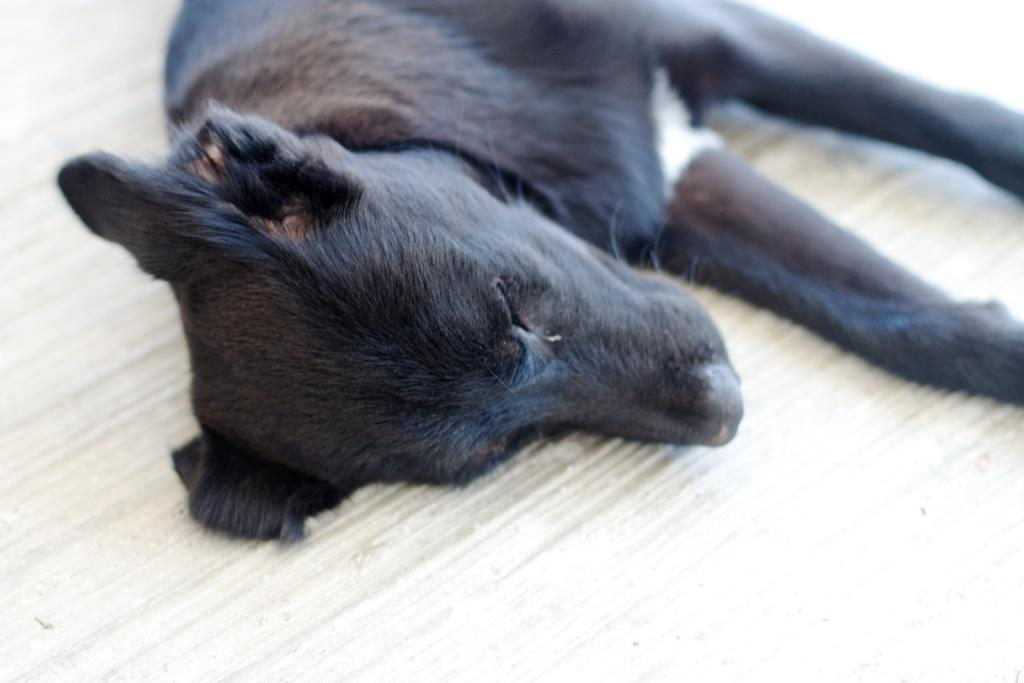What type of animal is in the image? There is a dog in the image. What color is the dog? The dog is black in color. What position is the dog in? The dog is lying on the floor. What word is being protested by the dog in the image? There is no protest or word present in the image; it features a black dog lying on the floor. 